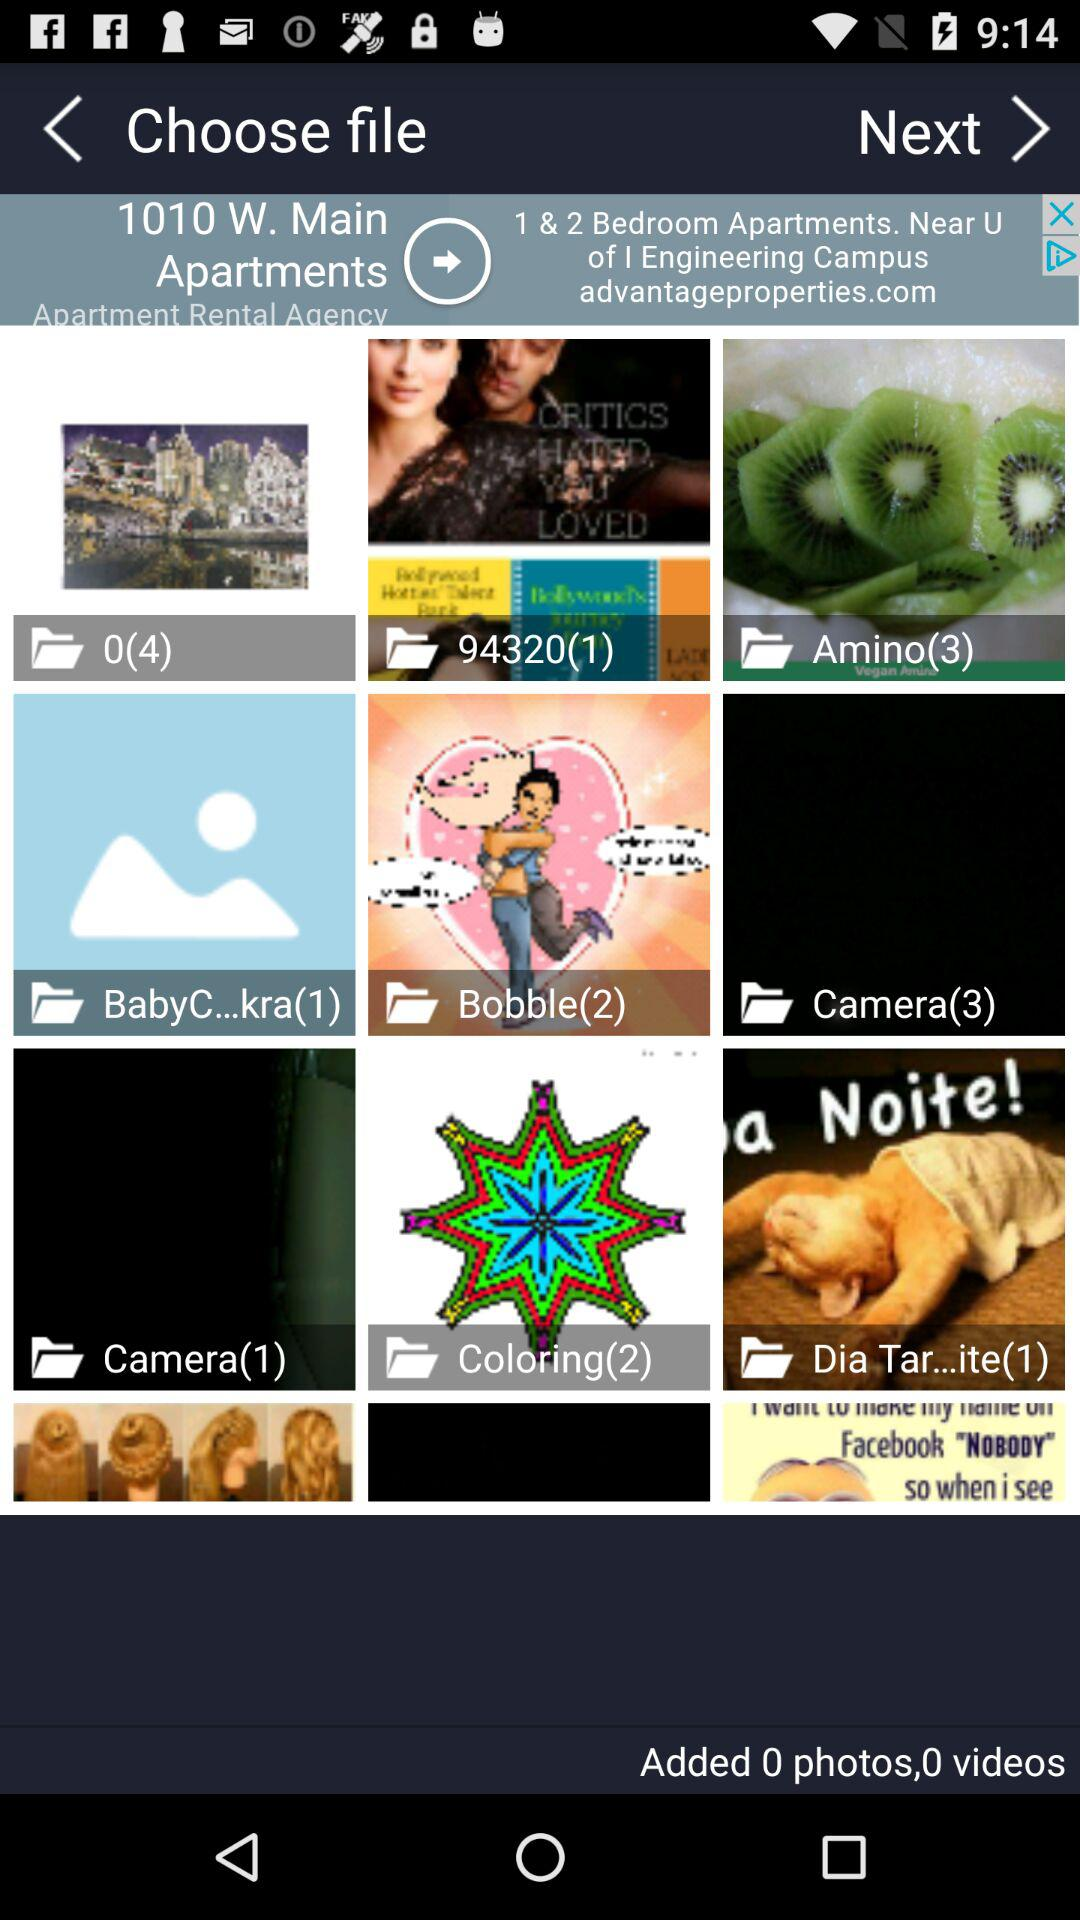What is the number of images in the "Camera" folder? The number of images in the "Camera" folders is 3 and 1. 